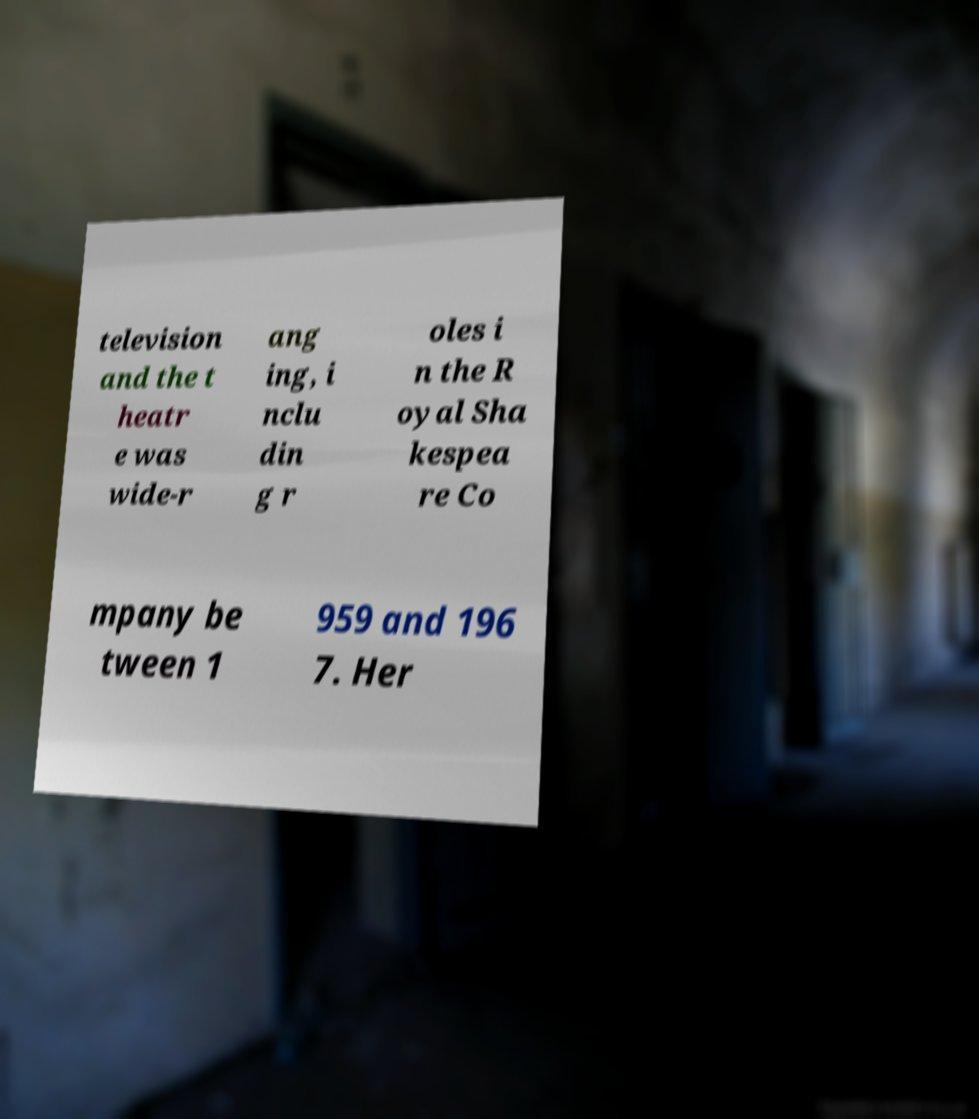Could you assist in decoding the text presented in this image and type it out clearly? television and the t heatr e was wide-r ang ing, i nclu din g r oles i n the R oyal Sha kespea re Co mpany be tween 1 959 and 196 7. Her 